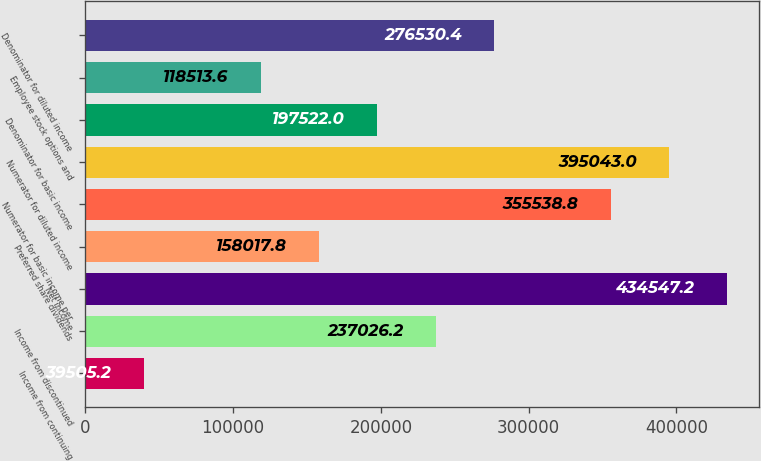Convert chart to OTSL. <chart><loc_0><loc_0><loc_500><loc_500><bar_chart><fcel>Income from continuing<fcel>Income from discontinued<fcel>Net income<fcel>Preferred share dividends<fcel>Numerator for basic income per<fcel>Numerator for diluted income<fcel>Denominator for basic income<fcel>Employee stock options and<fcel>Denominator for diluted income<nl><fcel>39505.2<fcel>237026<fcel>434547<fcel>158018<fcel>355539<fcel>395043<fcel>197522<fcel>118514<fcel>276530<nl></chart> 